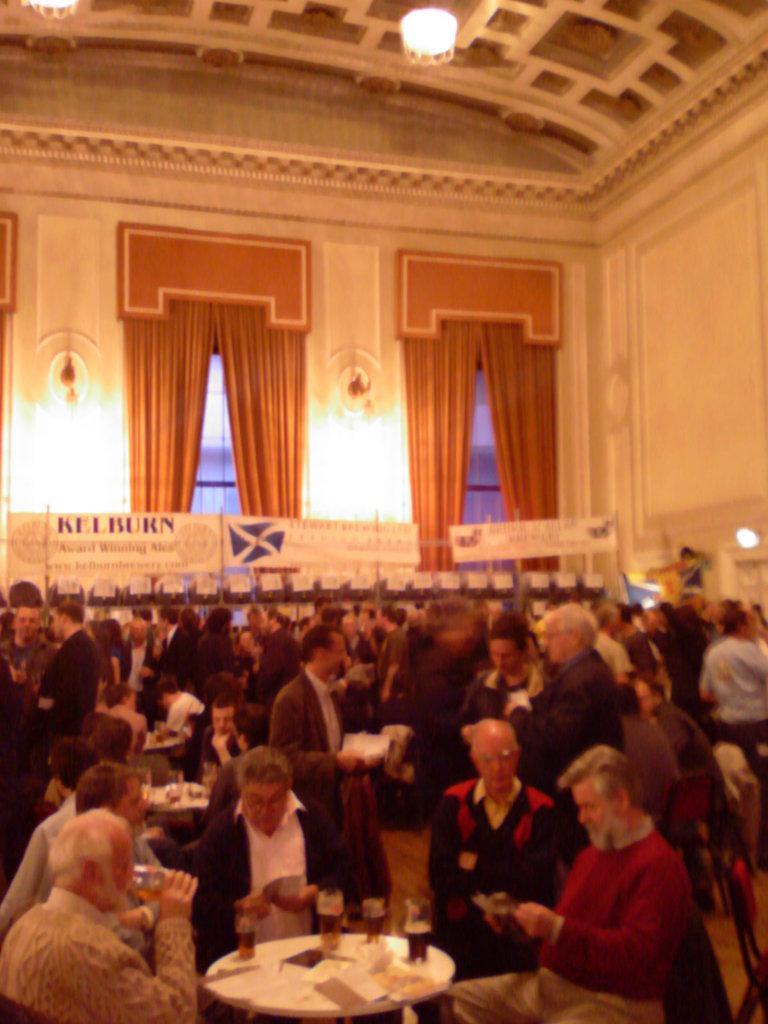Can you describe this image briefly? Here there is building two windows and curtains,people are sitting on the chair near the table and on the table there is glass and some papers are present here there are posters. 